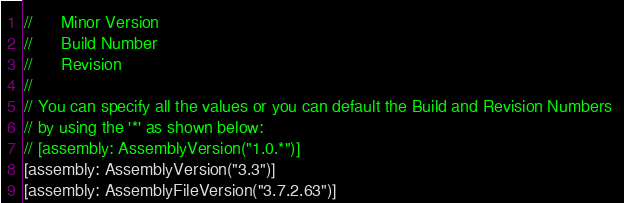Convert code to text. <code><loc_0><loc_0><loc_500><loc_500><_C#_>//      Minor Version 
//      Build Number
//      Revision
//
// You can specify all the values or you can default the Build and Revision Numbers 
// by using the '*' as shown below:
// [assembly: AssemblyVersion("1.0.*")]
[assembly: AssemblyVersion("3.3")]
[assembly: AssemblyFileVersion("3.7.2.63")]</code> 